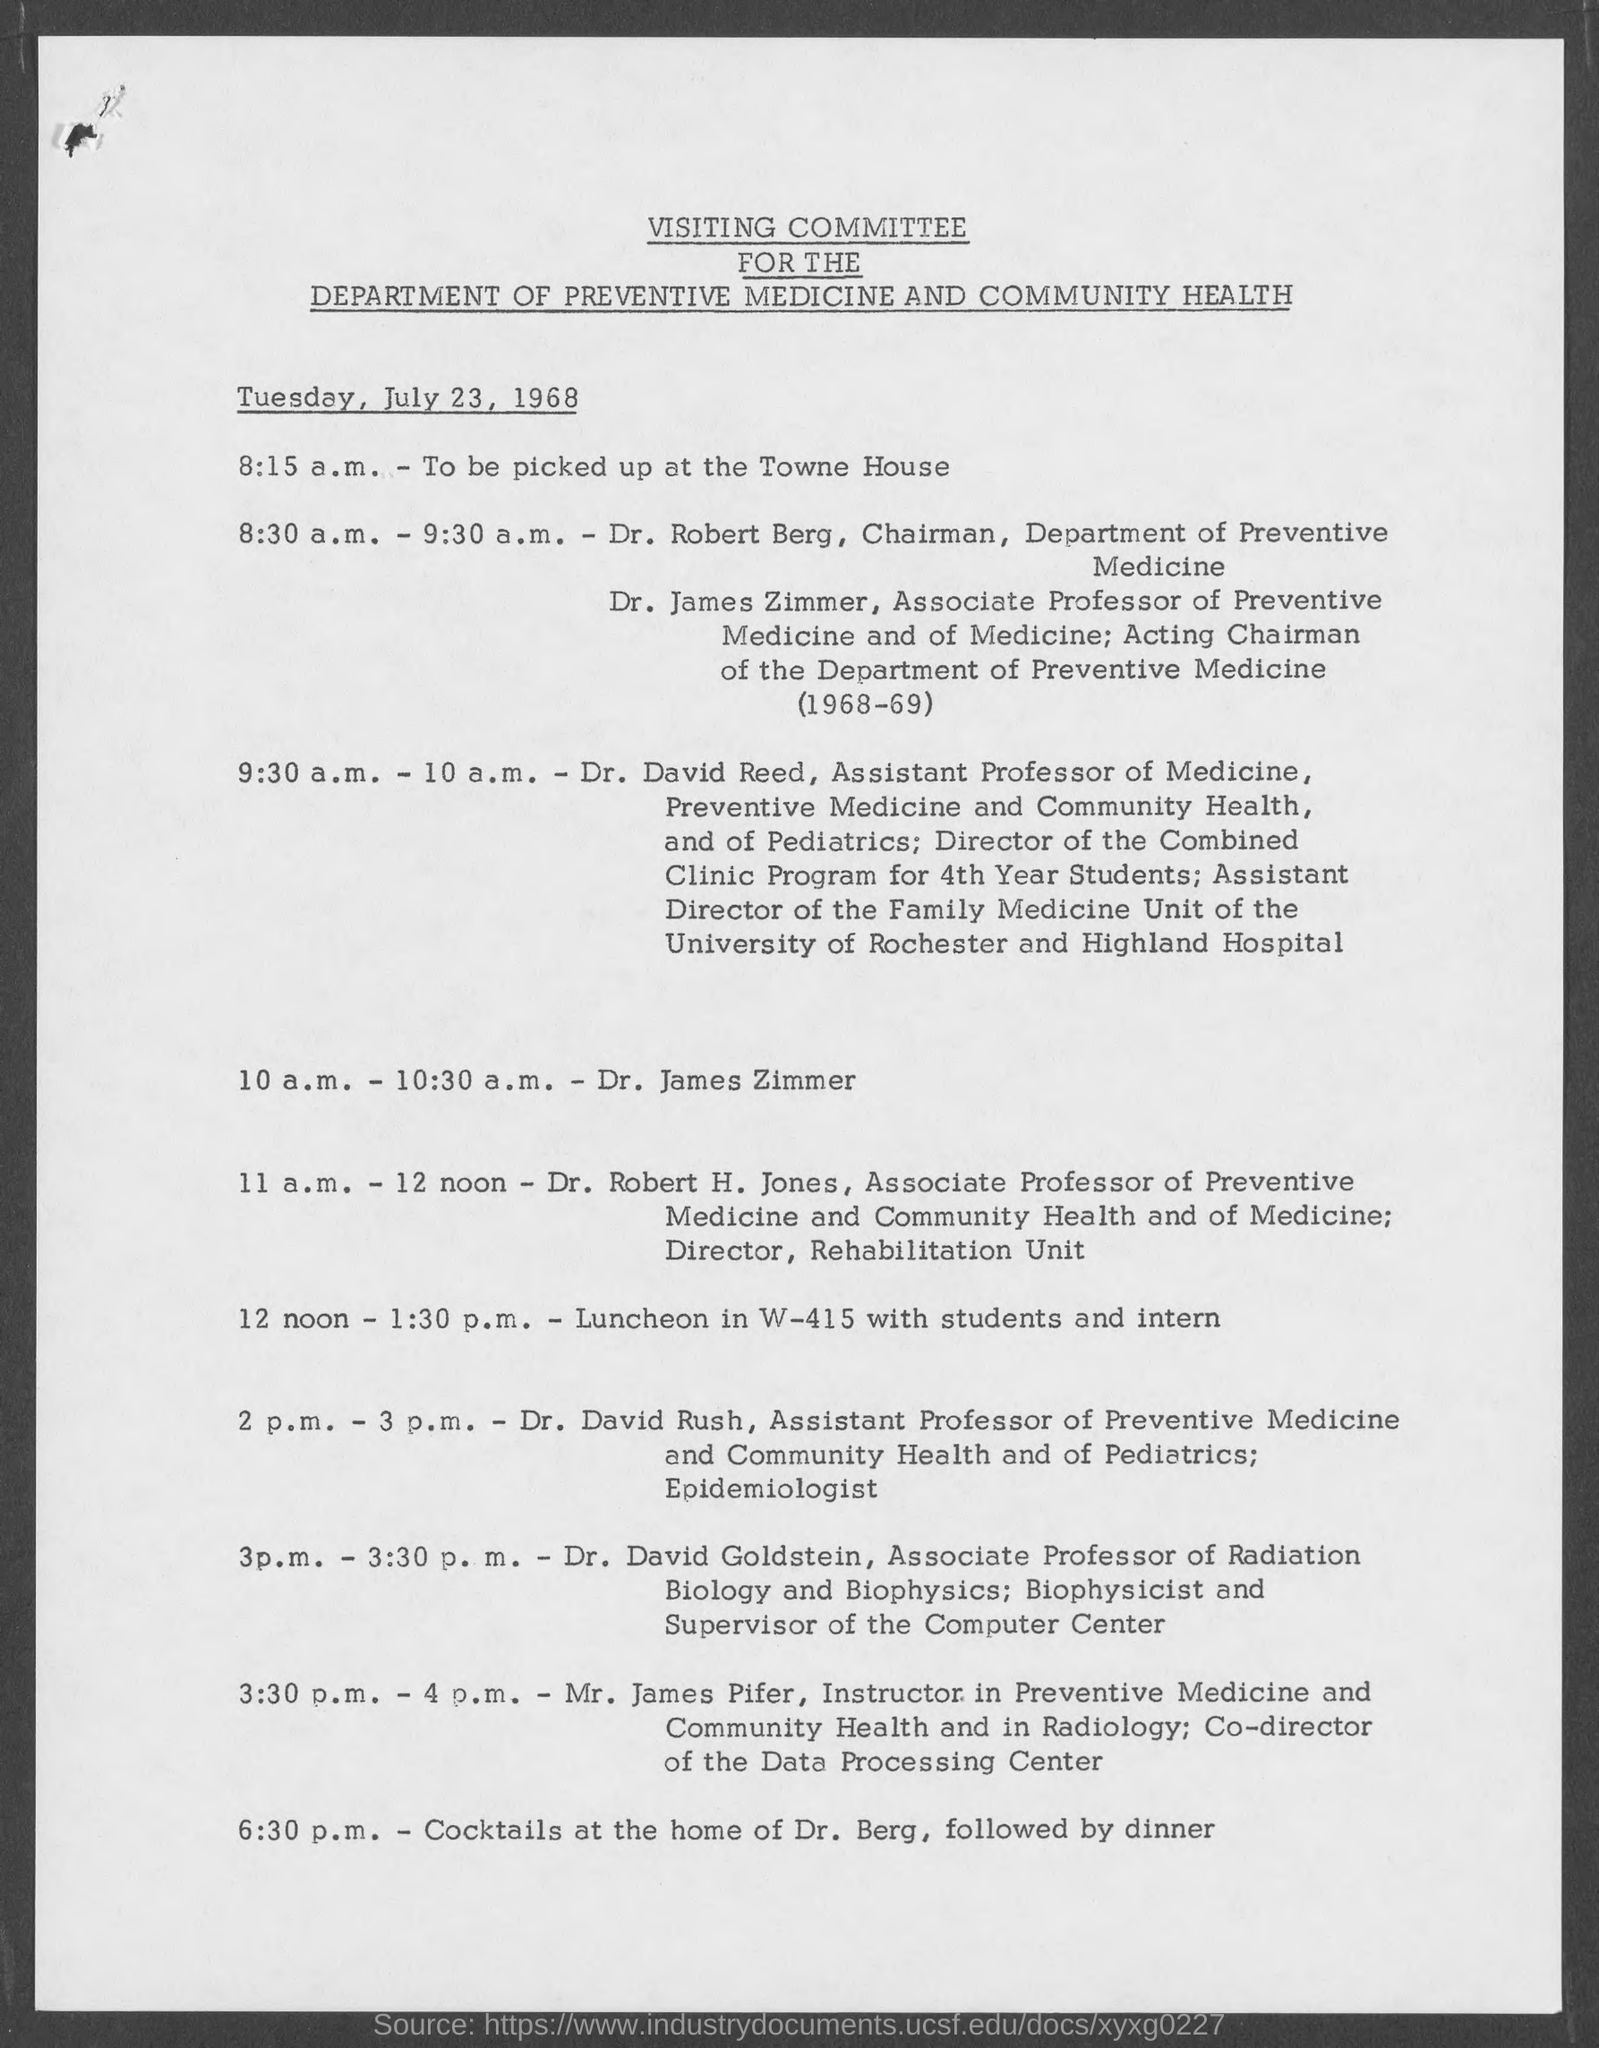Mention a couple of crucial points in this snapshot. The Chairman of the Department of Preventive Medicine is Dr. Robert Berg. The Department of Preventive Medicine and Community Health is the name of the department. 